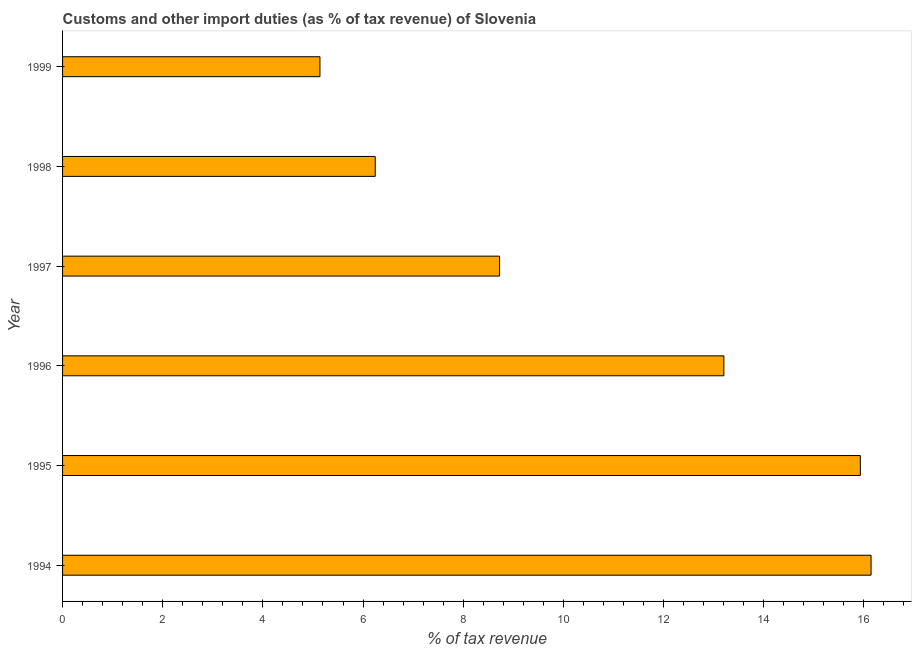Does the graph contain any zero values?
Make the answer very short. No. What is the title of the graph?
Offer a terse response. Customs and other import duties (as % of tax revenue) of Slovenia. What is the label or title of the X-axis?
Keep it short and to the point. % of tax revenue. What is the label or title of the Y-axis?
Your answer should be compact. Year. What is the customs and other import duties in 1997?
Keep it short and to the point. 8.73. Across all years, what is the maximum customs and other import duties?
Your answer should be very brief. 16.14. Across all years, what is the minimum customs and other import duties?
Provide a short and direct response. 5.14. What is the sum of the customs and other import duties?
Offer a very short reply. 65.39. What is the difference between the customs and other import duties in 1995 and 1999?
Offer a terse response. 10.79. What is the average customs and other import duties per year?
Ensure brevity in your answer.  10.9. What is the median customs and other import duties?
Give a very brief answer. 10.97. What is the ratio of the customs and other import duties in 1996 to that in 1998?
Ensure brevity in your answer.  2.12. Is the customs and other import duties in 1994 less than that in 1996?
Keep it short and to the point. No. What is the difference between the highest and the second highest customs and other import duties?
Give a very brief answer. 0.21. Is the sum of the customs and other import duties in 1997 and 1998 greater than the maximum customs and other import duties across all years?
Keep it short and to the point. No. In how many years, is the customs and other import duties greater than the average customs and other import duties taken over all years?
Offer a terse response. 3. Are all the bars in the graph horizontal?
Your response must be concise. Yes. Are the values on the major ticks of X-axis written in scientific E-notation?
Your response must be concise. No. What is the % of tax revenue in 1994?
Make the answer very short. 16.14. What is the % of tax revenue of 1995?
Your answer should be compact. 15.93. What is the % of tax revenue in 1996?
Give a very brief answer. 13.2. What is the % of tax revenue in 1997?
Your answer should be compact. 8.73. What is the % of tax revenue of 1998?
Offer a terse response. 6.24. What is the % of tax revenue in 1999?
Provide a succinct answer. 5.14. What is the difference between the % of tax revenue in 1994 and 1995?
Give a very brief answer. 0.21. What is the difference between the % of tax revenue in 1994 and 1996?
Your response must be concise. 2.94. What is the difference between the % of tax revenue in 1994 and 1997?
Your answer should be very brief. 7.42. What is the difference between the % of tax revenue in 1994 and 1998?
Provide a succinct answer. 9.9. What is the difference between the % of tax revenue in 1994 and 1999?
Ensure brevity in your answer.  11. What is the difference between the % of tax revenue in 1995 and 1996?
Offer a very short reply. 2.73. What is the difference between the % of tax revenue in 1995 and 1997?
Offer a very short reply. 7.2. What is the difference between the % of tax revenue in 1995 and 1998?
Your response must be concise. 9.69. What is the difference between the % of tax revenue in 1995 and 1999?
Give a very brief answer. 10.79. What is the difference between the % of tax revenue in 1996 and 1997?
Provide a short and direct response. 4.48. What is the difference between the % of tax revenue in 1996 and 1998?
Your response must be concise. 6.96. What is the difference between the % of tax revenue in 1996 and 1999?
Provide a short and direct response. 8.07. What is the difference between the % of tax revenue in 1997 and 1998?
Ensure brevity in your answer.  2.48. What is the difference between the % of tax revenue in 1997 and 1999?
Provide a succinct answer. 3.59. What is the difference between the % of tax revenue in 1998 and 1999?
Provide a short and direct response. 1.1. What is the ratio of the % of tax revenue in 1994 to that in 1996?
Ensure brevity in your answer.  1.22. What is the ratio of the % of tax revenue in 1994 to that in 1997?
Offer a very short reply. 1.85. What is the ratio of the % of tax revenue in 1994 to that in 1998?
Your answer should be very brief. 2.59. What is the ratio of the % of tax revenue in 1994 to that in 1999?
Ensure brevity in your answer.  3.14. What is the ratio of the % of tax revenue in 1995 to that in 1996?
Provide a short and direct response. 1.21. What is the ratio of the % of tax revenue in 1995 to that in 1997?
Your answer should be very brief. 1.83. What is the ratio of the % of tax revenue in 1995 to that in 1998?
Your response must be concise. 2.55. What is the ratio of the % of tax revenue in 1996 to that in 1997?
Offer a terse response. 1.51. What is the ratio of the % of tax revenue in 1996 to that in 1998?
Your answer should be compact. 2.12. What is the ratio of the % of tax revenue in 1996 to that in 1999?
Give a very brief answer. 2.57. What is the ratio of the % of tax revenue in 1997 to that in 1998?
Make the answer very short. 1.4. What is the ratio of the % of tax revenue in 1997 to that in 1999?
Provide a succinct answer. 1.7. What is the ratio of the % of tax revenue in 1998 to that in 1999?
Give a very brief answer. 1.22. 